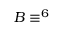<formula> <loc_0><loc_0><loc_500><loc_500>B \equiv ^ { 6 }</formula> 